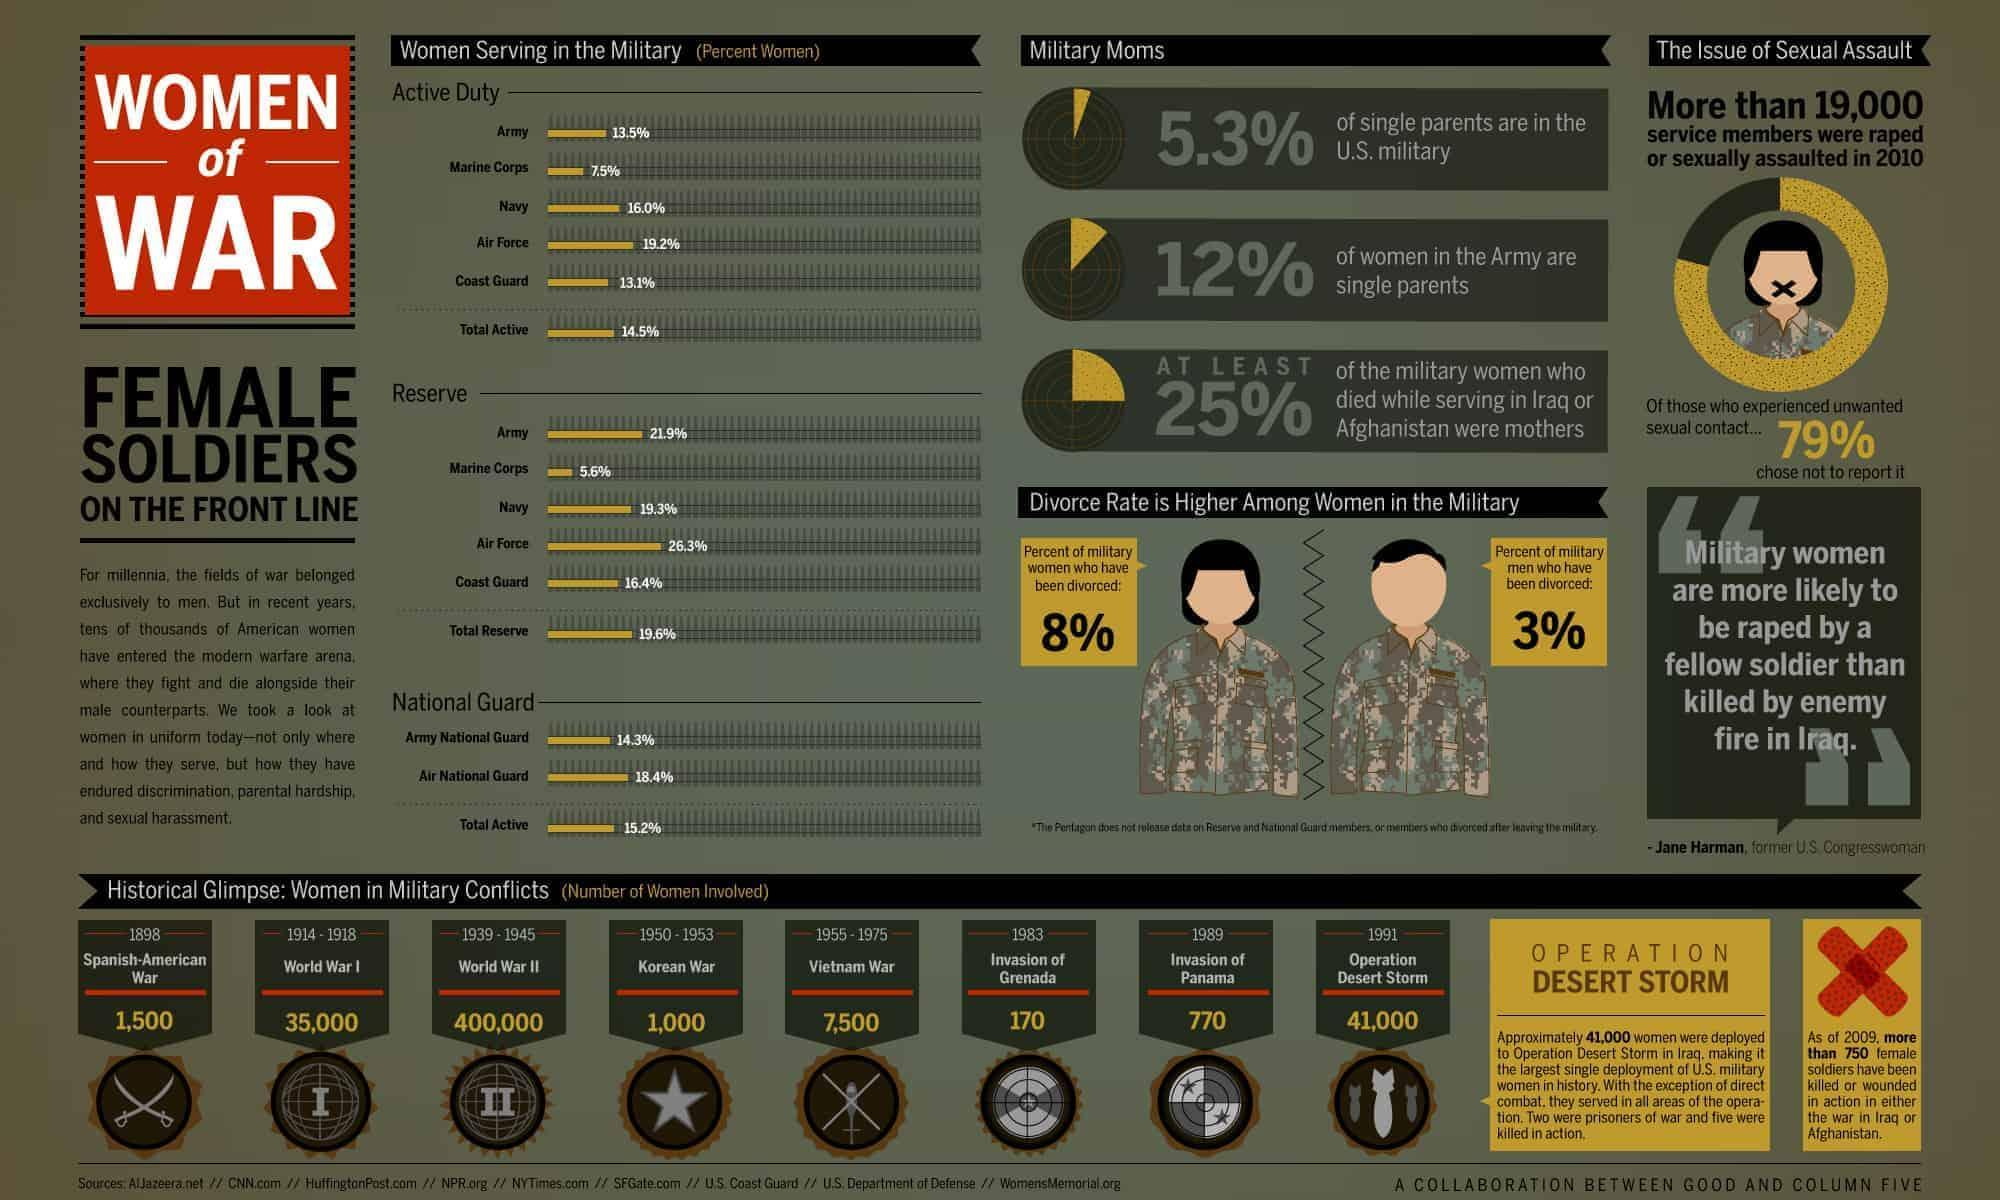When did the Korean War begin?
Answer the question with a short phrase. 1950 When did the Vietnam War end? 1975 What percent of women serve on active duty in the U.S. Navy ? 16.0% What percent of women serve on active duty in the U.S. Air National Guard? 18.4% How many American women were involved in the military during World War I? 35,000 How many American women were involved in the military during the Vietnam War? 7,500 What percent of U.S. women serve in the total reserve force? 19.6% When did the United States invade Grenada? 1983 